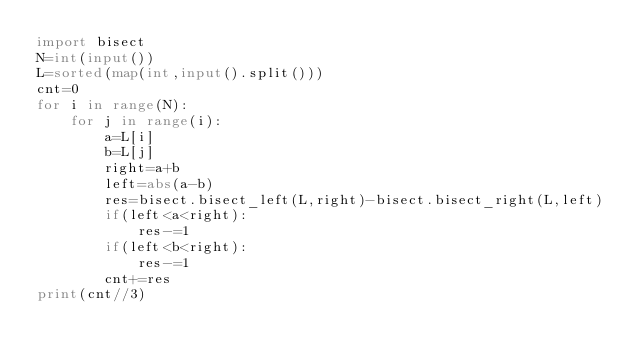Convert code to text. <code><loc_0><loc_0><loc_500><loc_500><_Python_>import bisect
N=int(input())
L=sorted(map(int,input().split()))
cnt=0
for i in range(N):
    for j in range(i):
        a=L[i]
        b=L[j]
        right=a+b
        left=abs(a-b)
        res=bisect.bisect_left(L,right)-bisect.bisect_right(L,left)
        if(left<a<right):
            res-=1
        if(left<b<right):
            res-=1
        cnt+=res
print(cnt//3)</code> 